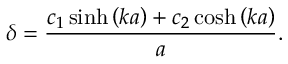Convert formula to latex. <formula><loc_0><loc_0><loc_500><loc_500>\delta = \frac { c _ { 1 } \sinh \left ( k a \right ) + c _ { 2 } \cosh \left ( k a \right ) } { a } .</formula> 